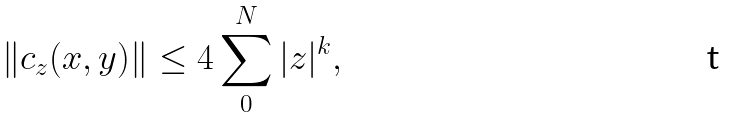Convert formula to latex. <formula><loc_0><loc_0><loc_500><loc_500>\| c _ { z } ( x , y ) \| \leq 4 \sum _ { 0 } ^ { N } | z | ^ { k } ,</formula> 